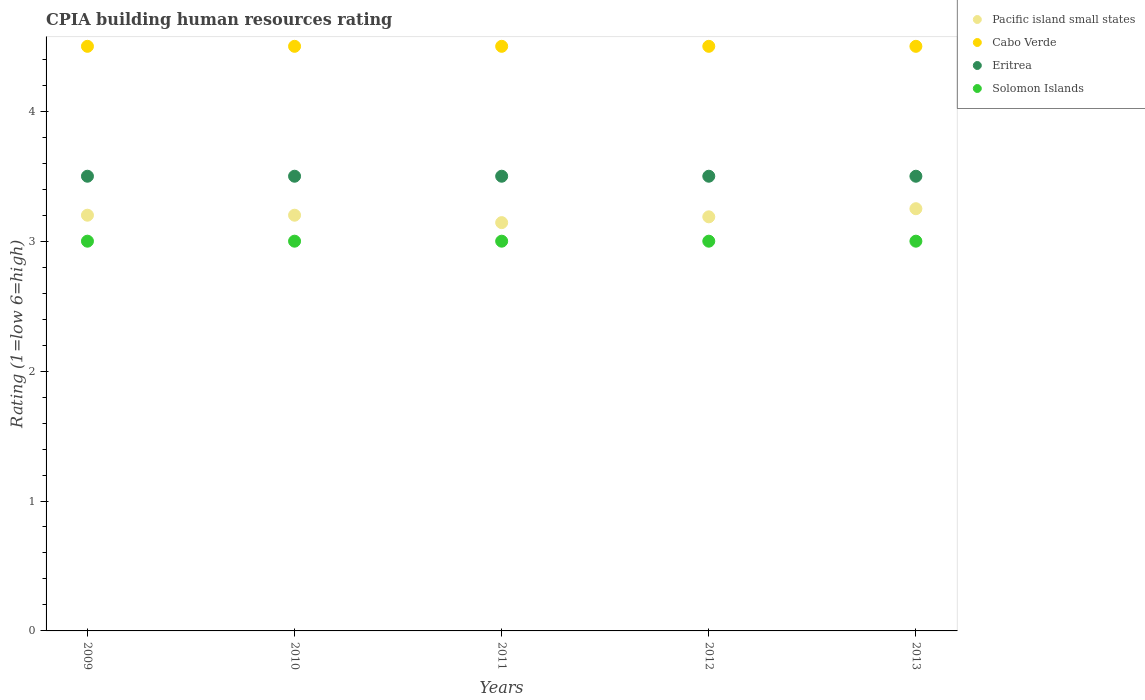What is the CPIA rating in Cabo Verde in 2011?
Offer a very short reply. 4.5. Across all years, what is the minimum CPIA rating in Solomon Islands?
Your response must be concise. 3. In which year was the CPIA rating in Eritrea maximum?
Ensure brevity in your answer.  2009. In which year was the CPIA rating in Eritrea minimum?
Ensure brevity in your answer.  2009. What is the total CPIA rating in Pacific island small states in the graph?
Offer a very short reply. 15.98. What is the difference between the CPIA rating in Solomon Islands in 2009 and that in 2012?
Ensure brevity in your answer.  0. What is the difference between the CPIA rating in Cabo Verde in 2011 and the CPIA rating in Eritrea in 2013?
Make the answer very short. 1. What is the average CPIA rating in Pacific island small states per year?
Keep it short and to the point. 3.2. In the year 2011, what is the difference between the CPIA rating in Pacific island small states and CPIA rating in Cabo Verde?
Provide a short and direct response. -1.36. What is the ratio of the CPIA rating in Solomon Islands in 2010 to that in 2013?
Offer a terse response. 1. Is the CPIA rating in Eritrea in 2010 less than that in 2012?
Keep it short and to the point. No. What is the difference between the highest and the second highest CPIA rating in Pacific island small states?
Offer a terse response. 0.05. Is the sum of the CPIA rating in Eritrea in 2010 and 2012 greater than the maximum CPIA rating in Pacific island small states across all years?
Provide a short and direct response. Yes. Is it the case that in every year, the sum of the CPIA rating in Eritrea and CPIA rating in Cabo Verde  is greater than the sum of CPIA rating in Pacific island small states and CPIA rating in Solomon Islands?
Provide a succinct answer. No. Is it the case that in every year, the sum of the CPIA rating in Solomon Islands and CPIA rating in Cabo Verde  is greater than the CPIA rating in Pacific island small states?
Your answer should be compact. Yes. Is the CPIA rating in Solomon Islands strictly greater than the CPIA rating in Cabo Verde over the years?
Provide a succinct answer. No. Is the CPIA rating in Pacific island small states strictly less than the CPIA rating in Cabo Verde over the years?
Provide a succinct answer. Yes. How many years are there in the graph?
Your response must be concise. 5. Are the values on the major ticks of Y-axis written in scientific E-notation?
Offer a terse response. No. Does the graph contain any zero values?
Ensure brevity in your answer.  No. Does the graph contain grids?
Offer a terse response. No. How many legend labels are there?
Your answer should be compact. 4. How are the legend labels stacked?
Your response must be concise. Vertical. What is the title of the graph?
Your answer should be compact. CPIA building human resources rating. Does "Denmark" appear as one of the legend labels in the graph?
Ensure brevity in your answer.  No. What is the Rating (1=low 6=high) of Eritrea in 2009?
Offer a very short reply. 3.5. What is the Rating (1=low 6=high) in Solomon Islands in 2009?
Your response must be concise. 3. What is the Rating (1=low 6=high) of Pacific island small states in 2010?
Your answer should be very brief. 3.2. What is the Rating (1=low 6=high) in Cabo Verde in 2010?
Make the answer very short. 4.5. What is the Rating (1=low 6=high) in Eritrea in 2010?
Ensure brevity in your answer.  3.5. What is the Rating (1=low 6=high) in Pacific island small states in 2011?
Your answer should be very brief. 3.14. What is the Rating (1=low 6=high) of Cabo Verde in 2011?
Provide a short and direct response. 4.5. What is the Rating (1=low 6=high) of Pacific island small states in 2012?
Keep it short and to the point. 3.19. What is the Rating (1=low 6=high) in Cabo Verde in 2012?
Keep it short and to the point. 4.5. What is the Rating (1=low 6=high) of Eritrea in 2012?
Your answer should be compact. 3.5. What is the Rating (1=low 6=high) in Solomon Islands in 2012?
Offer a terse response. 3. What is the Rating (1=low 6=high) of Cabo Verde in 2013?
Your answer should be very brief. 4.5. What is the Rating (1=low 6=high) in Eritrea in 2013?
Provide a succinct answer. 3.5. Across all years, what is the maximum Rating (1=low 6=high) of Pacific island small states?
Make the answer very short. 3.25. Across all years, what is the maximum Rating (1=low 6=high) in Cabo Verde?
Make the answer very short. 4.5. Across all years, what is the minimum Rating (1=low 6=high) of Pacific island small states?
Ensure brevity in your answer.  3.14. Across all years, what is the minimum Rating (1=low 6=high) of Cabo Verde?
Your response must be concise. 4.5. Across all years, what is the minimum Rating (1=low 6=high) in Solomon Islands?
Your answer should be compact. 3. What is the total Rating (1=low 6=high) in Pacific island small states in the graph?
Your response must be concise. 15.98. What is the difference between the Rating (1=low 6=high) of Pacific island small states in 2009 and that in 2010?
Your answer should be very brief. 0. What is the difference between the Rating (1=low 6=high) in Pacific island small states in 2009 and that in 2011?
Ensure brevity in your answer.  0.06. What is the difference between the Rating (1=low 6=high) of Cabo Verde in 2009 and that in 2011?
Your answer should be very brief. 0. What is the difference between the Rating (1=low 6=high) in Eritrea in 2009 and that in 2011?
Your answer should be compact. 0. What is the difference between the Rating (1=low 6=high) in Solomon Islands in 2009 and that in 2011?
Give a very brief answer. 0. What is the difference between the Rating (1=low 6=high) of Pacific island small states in 2009 and that in 2012?
Offer a very short reply. 0.01. What is the difference between the Rating (1=low 6=high) of Cabo Verde in 2009 and that in 2012?
Provide a short and direct response. 0. What is the difference between the Rating (1=low 6=high) of Cabo Verde in 2009 and that in 2013?
Ensure brevity in your answer.  0. What is the difference between the Rating (1=low 6=high) in Eritrea in 2009 and that in 2013?
Give a very brief answer. 0. What is the difference between the Rating (1=low 6=high) in Pacific island small states in 2010 and that in 2011?
Ensure brevity in your answer.  0.06. What is the difference between the Rating (1=low 6=high) of Solomon Islands in 2010 and that in 2011?
Your response must be concise. 0. What is the difference between the Rating (1=low 6=high) in Pacific island small states in 2010 and that in 2012?
Ensure brevity in your answer.  0.01. What is the difference between the Rating (1=low 6=high) of Solomon Islands in 2010 and that in 2012?
Your answer should be compact. 0. What is the difference between the Rating (1=low 6=high) in Pacific island small states in 2010 and that in 2013?
Offer a very short reply. -0.05. What is the difference between the Rating (1=low 6=high) in Solomon Islands in 2010 and that in 2013?
Provide a short and direct response. 0. What is the difference between the Rating (1=low 6=high) in Pacific island small states in 2011 and that in 2012?
Your answer should be compact. -0.04. What is the difference between the Rating (1=low 6=high) in Eritrea in 2011 and that in 2012?
Provide a short and direct response. 0. What is the difference between the Rating (1=low 6=high) in Solomon Islands in 2011 and that in 2012?
Make the answer very short. 0. What is the difference between the Rating (1=low 6=high) in Pacific island small states in 2011 and that in 2013?
Ensure brevity in your answer.  -0.11. What is the difference between the Rating (1=low 6=high) of Eritrea in 2011 and that in 2013?
Ensure brevity in your answer.  0. What is the difference between the Rating (1=low 6=high) of Solomon Islands in 2011 and that in 2013?
Give a very brief answer. 0. What is the difference between the Rating (1=low 6=high) of Pacific island small states in 2012 and that in 2013?
Your answer should be very brief. -0.06. What is the difference between the Rating (1=low 6=high) in Eritrea in 2012 and that in 2013?
Your response must be concise. 0. What is the difference between the Rating (1=low 6=high) of Solomon Islands in 2012 and that in 2013?
Provide a succinct answer. 0. What is the difference between the Rating (1=low 6=high) in Cabo Verde in 2009 and the Rating (1=low 6=high) in Solomon Islands in 2010?
Your answer should be compact. 1.5. What is the difference between the Rating (1=low 6=high) in Eritrea in 2009 and the Rating (1=low 6=high) in Solomon Islands in 2010?
Offer a terse response. 0.5. What is the difference between the Rating (1=low 6=high) in Pacific island small states in 2009 and the Rating (1=low 6=high) in Cabo Verde in 2011?
Ensure brevity in your answer.  -1.3. What is the difference between the Rating (1=low 6=high) of Pacific island small states in 2009 and the Rating (1=low 6=high) of Solomon Islands in 2011?
Provide a short and direct response. 0.2. What is the difference between the Rating (1=low 6=high) of Cabo Verde in 2009 and the Rating (1=low 6=high) of Solomon Islands in 2011?
Your answer should be very brief. 1.5. What is the difference between the Rating (1=low 6=high) of Pacific island small states in 2009 and the Rating (1=low 6=high) of Eritrea in 2013?
Make the answer very short. -0.3. What is the difference between the Rating (1=low 6=high) in Pacific island small states in 2009 and the Rating (1=low 6=high) in Solomon Islands in 2013?
Your answer should be compact. 0.2. What is the difference between the Rating (1=low 6=high) of Cabo Verde in 2009 and the Rating (1=low 6=high) of Eritrea in 2013?
Your answer should be compact. 1. What is the difference between the Rating (1=low 6=high) in Cabo Verde in 2009 and the Rating (1=low 6=high) in Solomon Islands in 2013?
Ensure brevity in your answer.  1.5. What is the difference between the Rating (1=low 6=high) in Eritrea in 2009 and the Rating (1=low 6=high) in Solomon Islands in 2013?
Offer a very short reply. 0.5. What is the difference between the Rating (1=low 6=high) in Cabo Verde in 2010 and the Rating (1=low 6=high) in Eritrea in 2011?
Offer a very short reply. 1. What is the difference between the Rating (1=low 6=high) of Cabo Verde in 2010 and the Rating (1=low 6=high) of Solomon Islands in 2011?
Offer a terse response. 1.5. What is the difference between the Rating (1=low 6=high) in Eritrea in 2010 and the Rating (1=low 6=high) in Solomon Islands in 2011?
Provide a short and direct response. 0.5. What is the difference between the Rating (1=low 6=high) in Cabo Verde in 2010 and the Rating (1=low 6=high) in Eritrea in 2012?
Offer a very short reply. 1. What is the difference between the Rating (1=low 6=high) of Cabo Verde in 2010 and the Rating (1=low 6=high) of Solomon Islands in 2012?
Offer a very short reply. 1.5. What is the difference between the Rating (1=low 6=high) in Pacific island small states in 2010 and the Rating (1=low 6=high) in Cabo Verde in 2013?
Offer a terse response. -1.3. What is the difference between the Rating (1=low 6=high) of Pacific island small states in 2010 and the Rating (1=low 6=high) of Eritrea in 2013?
Your response must be concise. -0.3. What is the difference between the Rating (1=low 6=high) of Cabo Verde in 2010 and the Rating (1=low 6=high) of Eritrea in 2013?
Your response must be concise. 1. What is the difference between the Rating (1=low 6=high) of Pacific island small states in 2011 and the Rating (1=low 6=high) of Cabo Verde in 2012?
Ensure brevity in your answer.  -1.36. What is the difference between the Rating (1=low 6=high) of Pacific island small states in 2011 and the Rating (1=low 6=high) of Eritrea in 2012?
Ensure brevity in your answer.  -0.36. What is the difference between the Rating (1=low 6=high) in Pacific island small states in 2011 and the Rating (1=low 6=high) in Solomon Islands in 2012?
Make the answer very short. 0.14. What is the difference between the Rating (1=low 6=high) of Cabo Verde in 2011 and the Rating (1=low 6=high) of Eritrea in 2012?
Offer a very short reply. 1. What is the difference between the Rating (1=low 6=high) in Pacific island small states in 2011 and the Rating (1=low 6=high) in Cabo Verde in 2013?
Make the answer very short. -1.36. What is the difference between the Rating (1=low 6=high) of Pacific island small states in 2011 and the Rating (1=low 6=high) of Eritrea in 2013?
Offer a very short reply. -0.36. What is the difference between the Rating (1=low 6=high) in Pacific island small states in 2011 and the Rating (1=low 6=high) in Solomon Islands in 2013?
Provide a short and direct response. 0.14. What is the difference between the Rating (1=low 6=high) in Cabo Verde in 2011 and the Rating (1=low 6=high) in Eritrea in 2013?
Offer a very short reply. 1. What is the difference between the Rating (1=low 6=high) of Cabo Verde in 2011 and the Rating (1=low 6=high) of Solomon Islands in 2013?
Offer a terse response. 1.5. What is the difference between the Rating (1=low 6=high) in Eritrea in 2011 and the Rating (1=low 6=high) in Solomon Islands in 2013?
Ensure brevity in your answer.  0.5. What is the difference between the Rating (1=low 6=high) of Pacific island small states in 2012 and the Rating (1=low 6=high) of Cabo Verde in 2013?
Keep it short and to the point. -1.31. What is the difference between the Rating (1=low 6=high) in Pacific island small states in 2012 and the Rating (1=low 6=high) in Eritrea in 2013?
Offer a terse response. -0.31. What is the difference between the Rating (1=low 6=high) in Pacific island small states in 2012 and the Rating (1=low 6=high) in Solomon Islands in 2013?
Provide a succinct answer. 0.19. What is the difference between the Rating (1=low 6=high) of Cabo Verde in 2012 and the Rating (1=low 6=high) of Eritrea in 2013?
Ensure brevity in your answer.  1. What is the difference between the Rating (1=low 6=high) in Cabo Verde in 2012 and the Rating (1=low 6=high) in Solomon Islands in 2013?
Make the answer very short. 1.5. What is the average Rating (1=low 6=high) in Pacific island small states per year?
Give a very brief answer. 3.2. What is the average Rating (1=low 6=high) in Eritrea per year?
Provide a short and direct response. 3.5. What is the average Rating (1=low 6=high) in Solomon Islands per year?
Provide a succinct answer. 3. In the year 2009, what is the difference between the Rating (1=low 6=high) in Cabo Verde and Rating (1=low 6=high) in Eritrea?
Ensure brevity in your answer.  1. In the year 2009, what is the difference between the Rating (1=low 6=high) of Cabo Verde and Rating (1=low 6=high) of Solomon Islands?
Your answer should be compact. 1.5. In the year 2010, what is the difference between the Rating (1=low 6=high) in Pacific island small states and Rating (1=low 6=high) in Cabo Verde?
Keep it short and to the point. -1.3. In the year 2010, what is the difference between the Rating (1=low 6=high) in Eritrea and Rating (1=low 6=high) in Solomon Islands?
Offer a very short reply. 0.5. In the year 2011, what is the difference between the Rating (1=low 6=high) in Pacific island small states and Rating (1=low 6=high) in Cabo Verde?
Your answer should be compact. -1.36. In the year 2011, what is the difference between the Rating (1=low 6=high) of Pacific island small states and Rating (1=low 6=high) of Eritrea?
Give a very brief answer. -0.36. In the year 2011, what is the difference between the Rating (1=low 6=high) of Pacific island small states and Rating (1=low 6=high) of Solomon Islands?
Your answer should be compact. 0.14. In the year 2011, what is the difference between the Rating (1=low 6=high) in Eritrea and Rating (1=low 6=high) in Solomon Islands?
Provide a short and direct response. 0.5. In the year 2012, what is the difference between the Rating (1=low 6=high) of Pacific island small states and Rating (1=low 6=high) of Cabo Verde?
Offer a very short reply. -1.31. In the year 2012, what is the difference between the Rating (1=low 6=high) in Pacific island small states and Rating (1=low 6=high) in Eritrea?
Offer a very short reply. -0.31. In the year 2012, what is the difference between the Rating (1=low 6=high) in Pacific island small states and Rating (1=low 6=high) in Solomon Islands?
Your answer should be compact. 0.19. In the year 2013, what is the difference between the Rating (1=low 6=high) in Pacific island small states and Rating (1=low 6=high) in Cabo Verde?
Your answer should be compact. -1.25. In the year 2013, what is the difference between the Rating (1=low 6=high) of Pacific island small states and Rating (1=low 6=high) of Solomon Islands?
Give a very brief answer. 0.25. In the year 2013, what is the difference between the Rating (1=low 6=high) of Cabo Verde and Rating (1=low 6=high) of Solomon Islands?
Provide a succinct answer. 1.5. In the year 2013, what is the difference between the Rating (1=low 6=high) of Eritrea and Rating (1=low 6=high) of Solomon Islands?
Make the answer very short. 0.5. What is the ratio of the Rating (1=low 6=high) of Pacific island small states in 2009 to that in 2011?
Keep it short and to the point. 1.02. What is the ratio of the Rating (1=low 6=high) in Eritrea in 2009 to that in 2011?
Ensure brevity in your answer.  1. What is the ratio of the Rating (1=low 6=high) in Solomon Islands in 2009 to that in 2011?
Keep it short and to the point. 1. What is the ratio of the Rating (1=low 6=high) in Pacific island small states in 2009 to that in 2012?
Give a very brief answer. 1. What is the ratio of the Rating (1=low 6=high) in Solomon Islands in 2009 to that in 2012?
Your answer should be compact. 1. What is the ratio of the Rating (1=low 6=high) of Pacific island small states in 2009 to that in 2013?
Offer a very short reply. 0.98. What is the ratio of the Rating (1=low 6=high) in Pacific island small states in 2010 to that in 2011?
Give a very brief answer. 1.02. What is the ratio of the Rating (1=low 6=high) in Cabo Verde in 2010 to that in 2011?
Your response must be concise. 1. What is the ratio of the Rating (1=low 6=high) in Eritrea in 2010 to that in 2011?
Provide a succinct answer. 1. What is the ratio of the Rating (1=low 6=high) of Solomon Islands in 2010 to that in 2011?
Keep it short and to the point. 1. What is the ratio of the Rating (1=low 6=high) of Pacific island small states in 2010 to that in 2012?
Make the answer very short. 1. What is the ratio of the Rating (1=low 6=high) of Cabo Verde in 2010 to that in 2012?
Your response must be concise. 1. What is the ratio of the Rating (1=low 6=high) in Pacific island small states in 2010 to that in 2013?
Keep it short and to the point. 0.98. What is the ratio of the Rating (1=low 6=high) of Solomon Islands in 2010 to that in 2013?
Provide a short and direct response. 1. What is the ratio of the Rating (1=low 6=high) in Cabo Verde in 2011 to that in 2012?
Offer a terse response. 1. What is the ratio of the Rating (1=low 6=high) of Eritrea in 2011 to that in 2012?
Provide a succinct answer. 1. What is the ratio of the Rating (1=low 6=high) in Solomon Islands in 2011 to that in 2012?
Give a very brief answer. 1. What is the ratio of the Rating (1=low 6=high) in Cabo Verde in 2011 to that in 2013?
Your response must be concise. 1. What is the ratio of the Rating (1=low 6=high) in Eritrea in 2011 to that in 2013?
Provide a succinct answer. 1. What is the ratio of the Rating (1=low 6=high) in Pacific island small states in 2012 to that in 2013?
Make the answer very short. 0.98. What is the ratio of the Rating (1=low 6=high) of Eritrea in 2012 to that in 2013?
Provide a short and direct response. 1. What is the difference between the highest and the second highest Rating (1=low 6=high) in Pacific island small states?
Keep it short and to the point. 0.05. What is the difference between the highest and the second highest Rating (1=low 6=high) in Cabo Verde?
Your response must be concise. 0. What is the difference between the highest and the second highest Rating (1=low 6=high) in Eritrea?
Your answer should be compact. 0. What is the difference between the highest and the lowest Rating (1=low 6=high) of Pacific island small states?
Make the answer very short. 0.11. What is the difference between the highest and the lowest Rating (1=low 6=high) of Solomon Islands?
Provide a short and direct response. 0. 